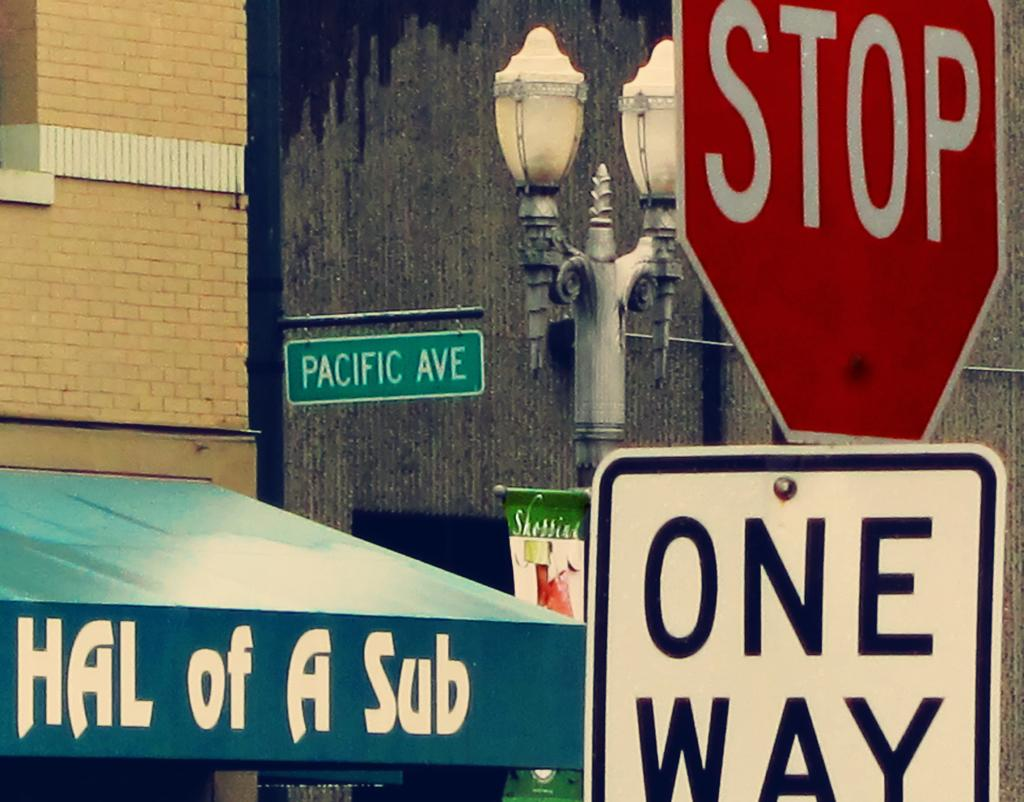<image>
Render a clear and concise summary of the photo. Hal of a sub restaurant on pacific ave with a one way sign and stop sign near 